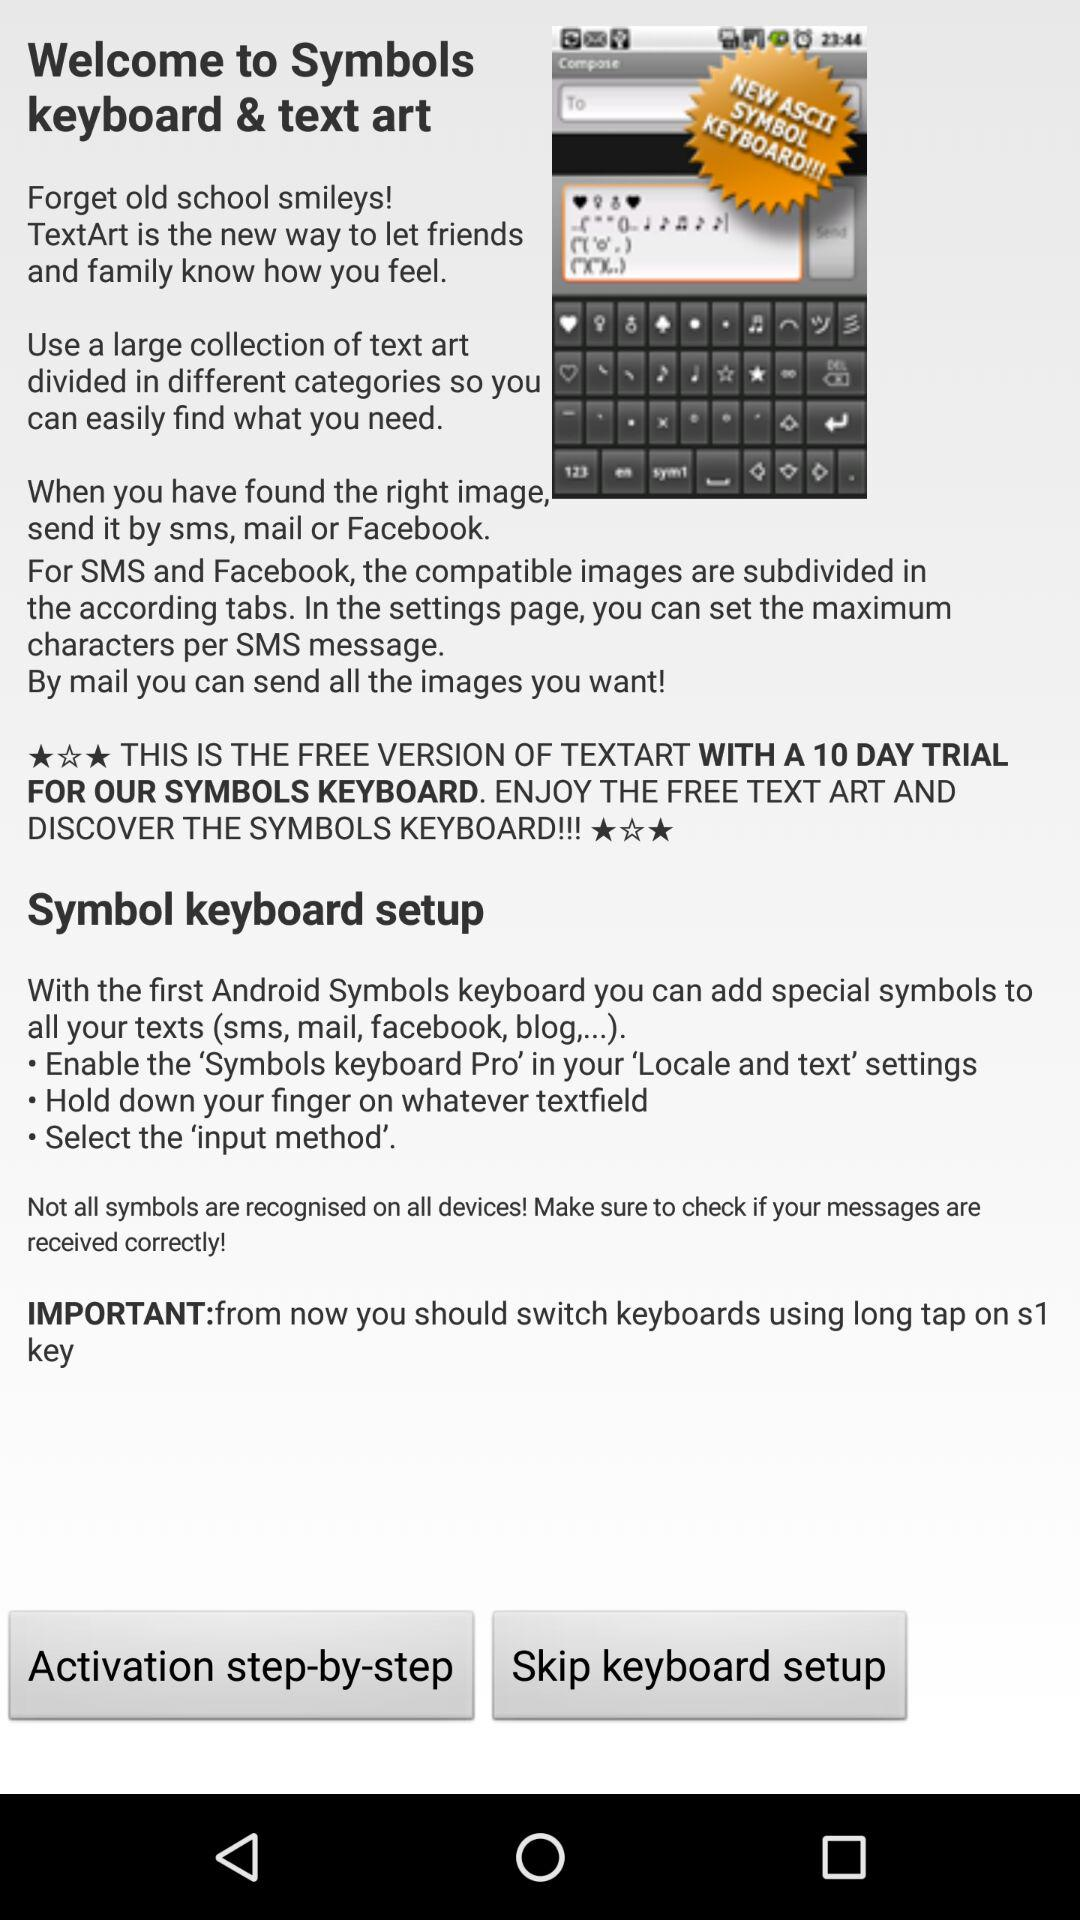How many days of trial are free for this application? There are 10 days. 